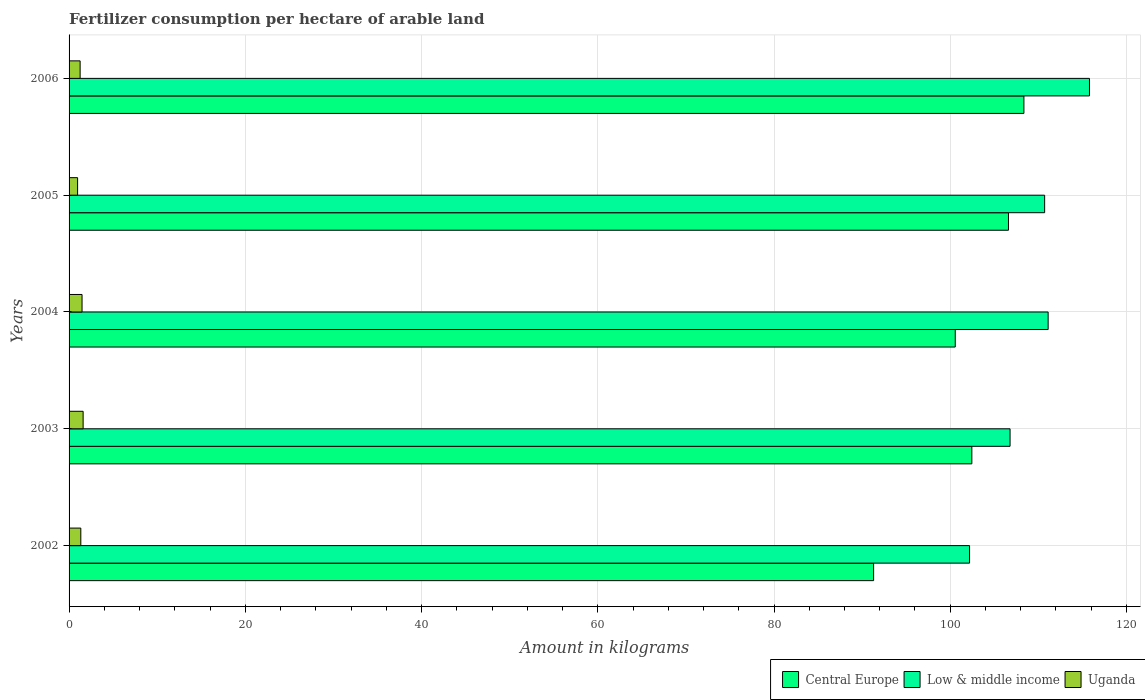How many groups of bars are there?
Make the answer very short. 5. How many bars are there on the 5th tick from the top?
Provide a succinct answer. 3. How many bars are there on the 2nd tick from the bottom?
Provide a short and direct response. 3. In how many cases, is the number of bars for a given year not equal to the number of legend labels?
Ensure brevity in your answer.  0. What is the amount of fertilizer consumption in Central Europe in 2002?
Make the answer very short. 91.3. Across all years, what is the maximum amount of fertilizer consumption in Low & middle income?
Provide a short and direct response. 115.8. Across all years, what is the minimum amount of fertilizer consumption in Low & middle income?
Your answer should be very brief. 102.19. In which year was the amount of fertilizer consumption in Central Europe maximum?
Your answer should be compact. 2006. In which year was the amount of fertilizer consumption in Low & middle income minimum?
Your answer should be very brief. 2002. What is the total amount of fertilizer consumption in Central Europe in the graph?
Offer a very short reply. 509.29. What is the difference between the amount of fertilizer consumption in Uganda in 2004 and that in 2006?
Keep it short and to the point. 0.22. What is the difference between the amount of fertilizer consumption in Low & middle income in 2004 and the amount of fertilizer consumption in Uganda in 2005?
Provide a short and direct response. 110.14. What is the average amount of fertilizer consumption in Low & middle income per year?
Keep it short and to the point. 109.32. In the year 2006, what is the difference between the amount of fertilizer consumption in Low & middle income and amount of fertilizer consumption in Uganda?
Your answer should be very brief. 114.55. What is the ratio of the amount of fertilizer consumption in Low & middle income in 2003 to that in 2005?
Your answer should be very brief. 0.96. Is the difference between the amount of fertilizer consumption in Low & middle income in 2003 and 2005 greater than the difference between the amount of fertilizer consumption in Uganda in 2003 and 2005?
Your response must be concise. No. What is the difference between the highest and the second highest amount of fertilizer consumption in Central Europe?
Your response must be concise. 1.75. What is the difference between the highest and the lowest amount of fertilizer consumption in Low & middle income?
Offer a very short reply. 13.61. In how many years, is the amount of fertilizer consumption in Uganda greater than the average amount of fertilizer consumption in Uganda taken over all years?
Ensure brevity in your answer.  3. Is the sum of the amount of fertilizer consumption in Uganda in 2003 and 2004 greater than the maximum amount of fertilizer consumption in Low & middle income across all years?
Provide a short and direct response. No. What does the 3rd bar from the top in 2005 represents?
Ensure brevity in your answer.  Central Europe. What does the 2nd bar from the bottom in 2006 represents?
Offer a terse response. Low & middle income. How many bars are there?
Offer a very short reply. 15. Are the values on the major ticks of X-axis written in scientific E-notation?
Your answer should be compact. No. Does the graph contain any zero values?
Offer a terse response. No. What is the title of the graph?
Offer a terse response. Fertilizer consumption per hectare of arable land. Does "Angola" appear as one of the legend labels in the graph?
Offer a terse response. No. What is the label or title of the X-axis?
Offer a terse response. Amount in kilograms. What is the Amount in kilograms in Central Europe in 2002?
Your answer should be very brief. 91.3. What is the Amount in kilograms in Low & middle income in 2002?
Make the answer very short. 102.19. What is the Amount in kilograms of Uganda in 2002?
Give a very brief answer. 1.33. What is the Amount in kilograms of Central Europe in 2003?
Offer a terse response. 102.45. What is the Amount in kilograms in Low & middle income in 2003?
Your answer should be very brief. 106.79. What is the Amount in kilograms of Uganda in 2003?
Your answer should be very brief. 1.6. What is the Amount in kilograms in Central Europe in 2004?
Provide a short and direct response. 100.57. What is the Amount in kilograms in Low & middle income in 2004?
Make the answer very short. 111.11. What is the Amount in kilograms of Uganda in 2004?
Offer a very short reply. 1.47. What is the Amount in kilograms of Central Europe in 2005?
Your answer should be very brief. 106.61. What is the Amount in kilograms in Low & middle income in 2005?
Ensure brevity in your answer.  110.71. What is the Amount in kilograms in Uganda in 2005?
Give a very brief answer. 0.97. What is the Amount in kilograms of Central Europe in 2006?
Your answer should be very brief. 108.36. What is the Amount in kilograms of Low & middle income in 2006?
Ensure brevity in your answer.  115.8. What is the Amount in kilograms in Uganda in 2006?
Offer a terse response. 1.25. Across all years, what is the maximum Amount in kilograms of Central Europe?
Offer a terse response. 108.36. Across all years, what is the maximum Amount in kilograms of Low & middle income?
Offer a very short reply. 115.8. Across all years, what is the maximum Amount in kilograms in Uganda?
Offer a very short reply. 1.6. Across all years, what is the minimum Amount in kilograms of Central Europe?
Make the answer very short. 91.3. Across all years, what is the minimum Amount in kilograms of Low & middle income?
Give a very brief answer. 102.19. Across all years, what is the minimum Amount in kilograms of Uganda?
Give a very brief answer. 0.97. What is the total Amount in kilograms of Central Europe in the graph?
Your answer should be compact. 509.29. What is the total Amount in kilograms of Low & middle income in the graph?
Ensure brevity in your answer.  546.61. What is the total Amount in kilograms in Uganda in the graph?
Keep it short and to the point. 6.62. What is the difference between the Amount in kilograms in Central Europe in 2002 and that in 2003?
Your response must be concise. -11.15. What is the difference between the Amount in kilograms in Low & middle income in 2002 and that in 2003?
Provide a short and direct response. -4.6. What is the difference between the Amount in kilograms in Uganda in 2002 and that in 2003?
Ensure brevity in your answer.  -0.26. What is the difference between the Amount in kilograms of Central Europe in 2002 and that in 2004?
Your answer should be very brief. -9.26. What is the difference between the Amount in kilograms of Low & middle income in 2002 and that in 2004?
Ensure brevity in your answer.  -8.92. What is the difference between the Amount in kilograms in Uganda in 2002 and that in 2004?
Provide a succinct answer. -0.14. What is the difference between the Amount in kilograms of Central Europe in 2002 and that in 2005?
Offer a terse response. -15.3. What is the difference between the Amount in kilograms in Low & middle income in 2002 and that in 2005?
Provide a succinct answer. -8.52. What is the difference between the Amount in kilograms of Uganda in 2002 and that in 2005?
Provide a succinct answer. 0.37. What is the difference between the Amount in kilograms in Central Europe in 2002 and that in 2006?
Your answer should be compact. -17.06. What is the difference between the Amount in kilograms in Low & middle income in 2002 and that in 2006?
Your response must be concise. -13.61. What is the difference between the Amount in kilograms in Uganda in 2002 and that in 2006?
Provide a succinct answer. 0.08. What is the difference between the Amount in kilograms of Central Europe in 2003 and that in 2004?
Make the answer very short. 1.88. What is the difference between the Amount in kilograms in Low & middle income in 2003 and that in 2004?
Your answer should be very brief. -4.32. What is the difference between the Amount in kilograms in Uganda in 2003 and that in 2004?
Make the answer very short. 0.12. What is the difference between the Amount in kilograms in Central Europe in 2003 and that in 2005?
Offer a terse response. -4.16. What is the difference between the Amount in kilograms in Low & middle income in 2003 and that in 2005?
Provide a succinct answer. -3.92. What is the difference between the Amount in kilograms of Uganda in 2003 and that in 2005?
Give a very brief answer. 0.63. What is the difference between the Amount in kilograms in Central Europe in 2003 and that in 2006?
Offer a very short reply. -5.91. What is the difference between the Amount in kilograms in Low & middle income in 2003 and that in 2006?
Offer a very short reply. -9.01. What is the difference between the Amount in kilograms of Uganda in 2003 and that in 2006?
Your response must be concise. 0.34. What is the difference between the Amount in kilograms of Central Europe in 2004 and that in 2005?
Provide a short and direct response. -6.04. What is the difference between the Amount in kilograms in Low & middle income in 2004 and that in 2005?
Your answer should be very brief. 0.4. What is the difference between the Amount in kilograms of Uganda in 2004 and that in 2005?
Make the answer very short. 0.5. What is the difference between the Amount in kilograms in Central Europe in 2004 and that in 2006?
Your response must be concise. -7.79. What is the difference between the Amount in kilograms of Low & middle income in 2004 and that in 2006?
Ensure brevity in your answer.  -4.69. What is the difference between the Amount in kilograms in Uganda in 2004 and that in 2006?
Keep it short and to the point. 0.22. What is the difference between the Amount in kilograms of Central Europe in 2005 and that in 2006?
Your answer should be very brief. -1.75. What is the difference between the Amount in kilograms of Low & middle income in 2005 and that in 2006?
Give a very brief answer. -5.09. What is the difference between the Amount in kilograms in Uganda in 2005 and that in 2006?
Your response must be concise. -0.29. What is the difference between the Amount in kilograms in Central Europe in 2002 and the Amount in kilograms in Low & middle income in 2003?
Your response must be concise. -15.48. What is the difference between the Amount in kilograms of Central Europe in 2002 and the Amount in kilograms of Uganda in 2003?
Provide a short and direct response. 89.71. What is the difference between the Amount in kilograms of Low & middle income in 2002 and the Amount in kilograms of Uganda in 2003?
Your answer should be compact. 100.6. What is the difference between the Amount in kilograms in Central Europe in 2002 and the Amount in kilograms in Low & middle income in 2004?
Offer a very short reply. -19.81. What is the difference between the Amount in kilograms of Central Europe in 2002 and the Amount in kilograms of Uganda in 2004?
Provide a succinct answer. 89.83. What is the difference between the Amount in kilograms in Low & middle income in 2002 and the Amount in kilograms in Uganda in 2004?
Your response must be concise. 100.72. What is the difference between the Amount in kilograms in Central Europe in 2002 and the Amount in kilograms in Low & middle income in 2005?
Your answer should be compact. -19.41. What is the difference between the Amount in kilograms in Central Europe in 2002 and the Amount in kilograms in Uganda in 2005?
Make the answer very short. 90.34. What is the difference between the Amount in kilograms in Low & middle income in 2002 and the Amount in kilograms in Uganda in 2005?
Provide a succinct answer. 101.23. What is the difference between the Amount in kilograms of Central Europe in 2002 and the Amount in kilograms of Low & middle income in 2006?
Provide a succinct answer. -24.5. What is the difference between the Amount in kilograms of Central Europe in 2002 and the Amount in kilograms of Uganda in 2006?
Give a very brief answer. 90.05. What is the difference between the Amount in kilograms in Low & middle income in 2002 and the Amount in kilograms in Uganda in 2006?
Keep it short and to the point. 100.94. What is the difference between the Amount in kilograms of Central Europe in 2003 and the Amount in kilograms of Low & middle income in 2004?
Ensure brevity in your answer.  -8.66. What is the difference between the Amount in kilograms in Central Europe in 2003 and the Amount in kilograms in Uganda in 2004?
Give a very brief answer. 100.98. What is the difference between the Amount in kilograms of Low & middle income in 2003 and the Amount in kilograms of Uganda in 2004?
Give a very brief answer. 105.32. What is the difference between the Amount in kilograms in Central Europe in 2003 and the Amount in kilograms in Low & middle income in 2005?
Offer a terse response. -8.26. What is the difference between the Amount in kilograms in Central Europe in 2003 and the Amount in kilograms in Uganda in 2005?
Offer a very short reply. 101.49. What is the difference between the Amount in kilograms of Low & middle income in 2003 and the Amount in kilograms of Uganda in 2005?
Give a very brief answer. 105.82. What is the difference between the Amount in kilograms in Central Europe in 2003 and the Amount in kilograms in Low & middle income in 2006?
Give a very brief answer. -13.35. What is the difference between the Amount in kilograms of Central Europe in 2003 and the Amount in kilograms of Uganda in 2006?
Your response must be concise. 101.2. What is the difference between the Amount in kilograms of Low & middle income in 2003 and the Amount in kilograms of Uganda in 2006?
Your response must be concise. 105.53. What is the difference between the Amount in kilograms in Central Europe in 2004 and the Amount in kilograms in Low & middle income in 2005?
Provide a succinct answer. -10.14. What is the difference between the Amount in kilograms of Central Europe in 2004 and the Amount in kilograms of Uganda in 2005?
Make the answer very short. 99.6. What is the difference between the Amount in kilograms in Low & middle income in 2004 and the Amount in kilograms in Uganda in 2005?
Your response must be concise. 110.14. What is the difference between the Amount in kilograms of Central Europe in 2004 and the Amount in kilograms of Low & middle income in 2006?
Your answer should be compact. -15.23. What is the difference between the Amount in kilograms of Central Europe in 2004 and the Amount in kilograms of Uganda in 2006?
Your answer should be compact. 99.31. What is the difference between the Amount in kilograms of Low & middle income in 2004 and the Amount in kilograms of Uganda in 2006?
Give a very brief answer. 109.86. What is the difference between the Amount in kilograms of Central Europe in 2005 and the Amount in kilograms of Low & middle income in 2006?
Your response must be concise. -9.19. What is the difference between the Amount in kilograms of Central Europe in 2005 and the Amount in kilograms of Uganda in 2006?
Provide a short and direct response. 105.35. What is the difference between the Amount in kilograms of Low & middle income in 2005 and the Amount in kilograms of Uganda in 2006?
Your answer should be compact. 109.46. What is the average Amount in kilograms of Central Europe per year?
Offer a very short reply. 101.86. What is the average Amount in kilograms in Low & middle income per year?
Provide a succinct answer. 109.32. What is the average Amount in kilograms in Uganda per year?
Ensure brevity in your answer.  1.32. In the year 2002, what is the difference between the Amount in kilograms of Central Europe and Amount in kilograms of Low & middle income?
Ensure brevity in your answer.  -10.89. In the year 2002, what is the difference between the Amount in kilograms in Central Europe and Amount in kilograms in Uganda?
Your answer should be compact. 89.97. In the year 2002, what is the difference between the Amount in kilograms of Low & middle income and Amount in kilograms of Uganda?
Offer a very short reply. 100.86. In the year 2003, what is the difference between the Amount in kilograms of Central Europe and Amount in kilograms of Low & middle income?
Offer a very short reply. -4.34. In the year 2003, what is the difference between the Amount in kilograms of Central Europe and Amount in kilograms of Uganda?
Your response must be concise. 100.86. In the year 2003, what is the difference between the Amount in kilograms in Low & middle income and Amount in kilograms in Uganda?
Give a very brief answer. 105.19. In the year 2004, what is the difference between the Amount in kilograms in Central Europe and Amount in kilograms in Low & middle income?
Make the answer very short. -10.54. In the year 2004, what is the difference between the Amount in kilograms of Central Europe and Amount in kilograms of Uganda?
Offer a very short reply. 99.1. In the year 2004, what is the difference between the Amount in kilograms of Low & middle income and Amount in kilograms of Uganda?
Your response must be concise. 109.64. In the year 2005, what is the difference between the Amount in kilograms of Central Europe and Amount in kilograms of Low & middle income?
Provide a succinct answer. -4.11. In the year 2005, what is the difference between the Amount in kilograms of Central Europe and Amount in kilograms of Uganda?
Give a very brief answer. 105.64. In the year 2005, what is the difference between the Amount in kilograms of Low & middle income and Amount in kilograms of Uganda?
Keep it short and to the point. 109.75. In the year 2006, what is the difference between the Amount in kilograms of Central Europe and Amount in kilograms of Low & middle income?
Your answer should be very brief. -7.44. In the year 2006, what is the difference between the Amount in kilograms of Central Europe and Amount in kilograms of Uganda?
Provide a succinct answer. 107.11. In the year 2006, what is the difference between the Amount in kilograms in Low & middle income and Amount in kilograms in Uganda?
Your answer should be very brief. 114.55. What is the ratio of the Amount in kilograms in Central Europe in 2002 to that in 2003?
Your response must be concise. 0.89. What is the ratio of the Amount in kilograms of Low & middle income in 2002 to that in 2003?
Offer a terse response. 0.96. What is the ratio of the Amount in kilograms of Uganda in 2002 to that in 2003?
Your response must be concise. 0.84. What is the ratio of the Amount in kilograms in Central Europe in 2002 to that in 2004?
Ensure brevity in your answer.  0.91. What is the ratio of the Amount in kilograms of Low & middle income in 2002 to that in 2004?
Keep it short and to the point. 0.92. What is the ratio of the Amount in kilograms of Uganda in 2002 to that in 2004?
Ensure brevity in your answer.  0.91. What is the ratio of the Amount in kilograms in Central Europe in 2002 to that in 2005?
Make the answer very short. 0.86. What is the ratio of the Amount in kilograms of Low & middle income in 2002 to that in 2005?
Provide a succinct answer. 0.92. What is the ratio of the Amount in kilograms in Uganda in 2002 to that in 2005?
Provide a succinct answer. 1.38. What is the ratio of the Amount in kilograms of Central Europe in 2002 to that in 2006?
Keep it short and to the point. 0.84. What is the ratio of the Amount in kilograms of Low & middle income in 2002 to that in 2006?
Provide a short and direct response. 0.88. What is the ratio of the Amount in kilograms in Uganda in 2002 to that in 2006?
Your answer should be compact. 1.06. What is the ratio of the Amount in kilograms in Central Europe in 2003 to that in 2004?
Make the answer very short. 1.02. What is the ratio of the Amount in kilograms of Low & middle income in 2003 to that in 2004?
Your answer should be compact. 0.96. What is the ratio of the Amount in kilograms of Uganda in 2003 to that in 2004?
Keep it short and to the point. 1.08. What is the ratio of the Amount in kilograms of Low & middle income in 2003 to that in 2005?
Your answer should be compact. 0.96. What is the ratio of the Amount in kilograms in Uganda in 2003 to that in 2005?
Ensure brevity in your answer.  1.65. What is the ratio of the Amount in kilograms of Central Europe in 2003 to that in 2006?
Provide a short and direct response. 0.95. What is the ratio of the Amount in kilograms of Low & middle income in 2003 to that in 2006?
Make the answer very short. 0.92. What is the ratio of the Amount in kilograms of Uganda in 2003 to that in 2006?
Your answer should be very brief. 1.27. What is the ratio of the Amount in kilograms in Central Europe in 2004 to that in 2005?
Your answer should be compact. 0.94. What is the ratio of the Amount in kilograms in Low & middle income in 2004 to that in 2005?
Provide a succinct answer. 1. What is the ratio of the Amount in kilograms of Uganda in 2004 to that in 2005?
Your response must be concise. 1.52. What is the ratio of the Amount in kilograms of Central Europe in 2004 to that in 2006?
Keep it short and to the point. 0.93. What is the ratio of the Amount in kilograms in Low & middle income in 2004 to that in 2006?
Provide a succinct answer. 0.96. What is the ratio of the Amount in kilograms in Uganda in 2004 to that in 2006?
Offer a very short reply. 1.17. What is the ratio of the Amount in kilograms of Central Europe in 2005 to that in 2006?
Your answer should be compact. 0.98. What is the ratio of the Amount in kilograms in Low & middle income in 2005 to that in 2006?
Offer a very short reply. 0.96. What is the ratio of the Amount in kilograms of Uganda in 2005 to that in 2006?
Give a very brief answer. 0.77. What is the difference between the highest and the second highest Amount in kilograms of Central Europe?
Offer a very short reply. 1.75. What is the difference between the highest and the second highest Amount in kilograms in Low & middle income?
Your answer should be compact. 4.69. What is the difference between the highest and the second highest Amount in kilograms of Uganda?
Offer a terse response. 0.12. What is the difference between the highest and the lowest Amount in kilograms in Central Europe?
Give a very brief answer. 17.06. What is the difference between the highest and the lowest Amount in kilograms of Low & middle income?
Provide a short and direct response. 13.61. What is the difference between the highest and the lowest Amount in kilograms in Uganda?
Keep it short and to the point. 0.63. 